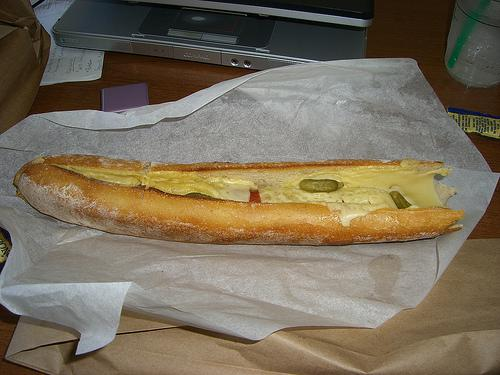Question: who is in the picture?
Choices:
A. A girl.
B. A boy.
C. A family.
D. No one.
Answer with the letter. Answer: D Question: where is the sub located?
Choices:
A. In a wrapper.
B. On the counter.
C. On the kitchen table.
D. On a desk.
Answer with the letter. Answer: D 